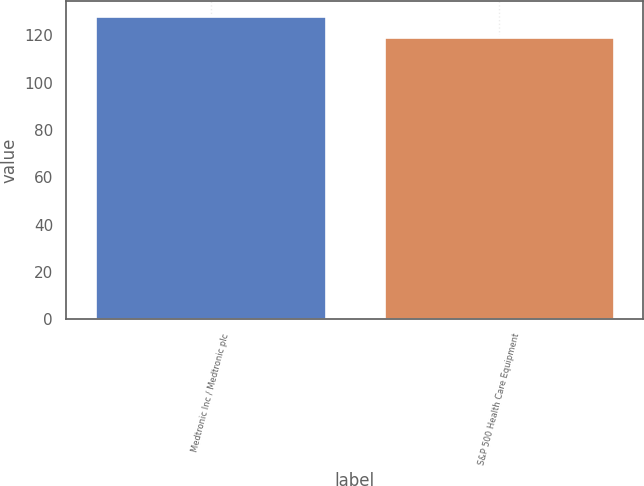Convert chart. <chart><loc_0><loc_0><loc_500><loc_500><bar_chart><fcel>Medtronic Inc / Medtronic plc<fcel>S&P 500 Health Care Equipment<nl><fcel>128.1<fcel>119.09<nl></chart> 